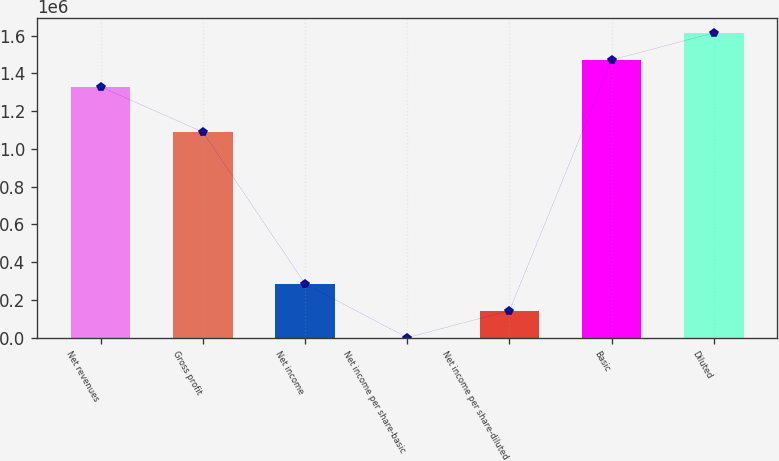Convert chart to OTSL. <chart><loc_0><loc_0><loc_500><loc_500><bar_chart><fcel>Net revenues<fcel>Gross profit<fcel>Net income<fcel>Net income per share-basic<fcel>Net income per share-diluted<fcel>Basic<fcel>Diluted<nl><fcel>1.32886e+06<fcel>1.08934e+06<fcel>285295<fcel>0.2<fcel>142648<fcel>1.47151e+06<fcel>1.61415e+06<nl></chart> 